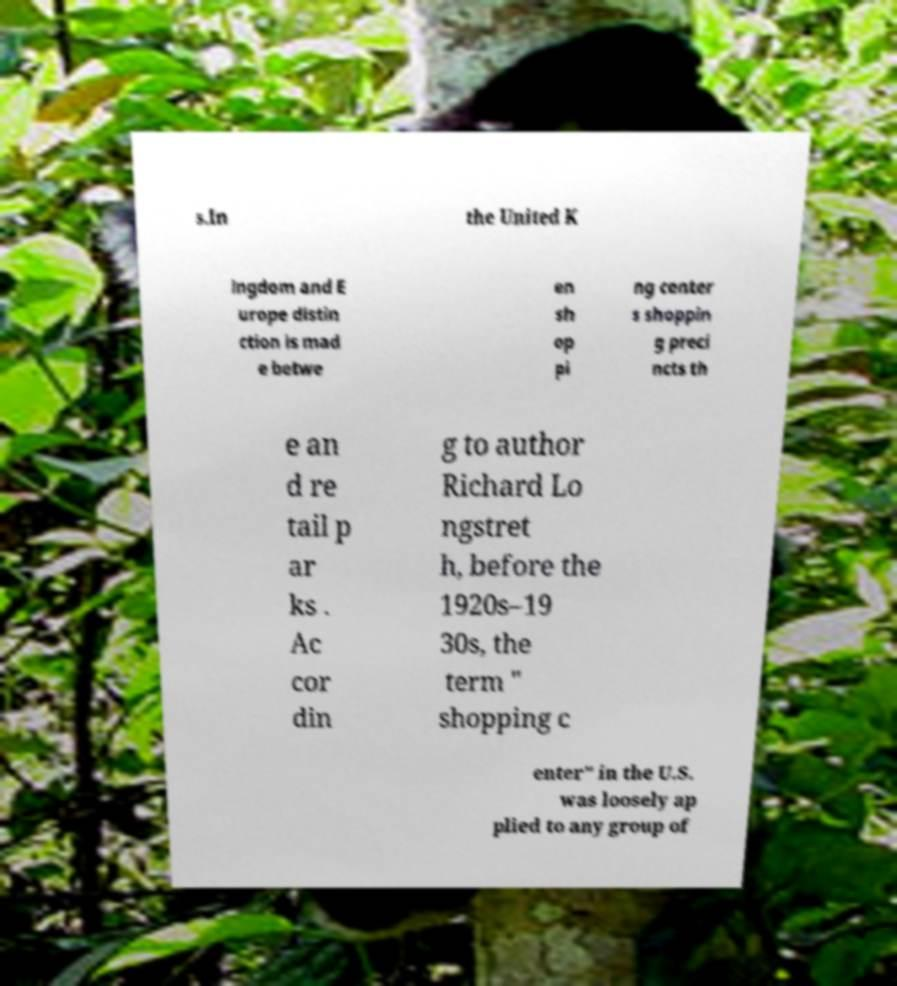What messages or text are displayed in this image? I need them in a readable, typed format. s.In the United K ingdom and E urope distin ction is mad e betwe en sh op pi ng center s shoppin g preci ncts th e an d re tail p ar ks . Ac cor din g to author Richard Lo ngstret h, before the 1920s–19 30s, the term " shopping c enter" in the U.S. was loosely ap plied to any group of 